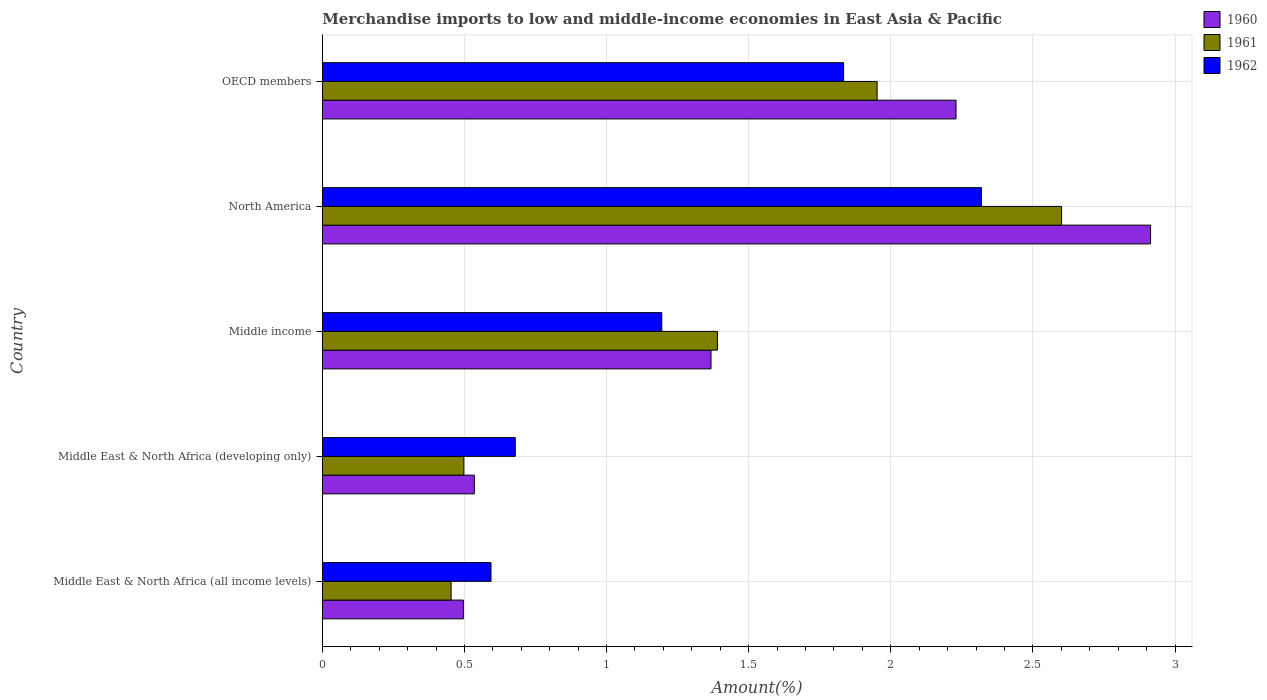How many groups of bars are there?
Your answer should be compact. 5. Are the number of bars on each tick of the Y-axis equal?
Provide a succinct answer. Yes. How many bars are there on the 4th tick from the top?
Offer a terse response. 3. What is the percentage of amount earned from merchandise imports in 1960 in Middle East & North Africa (developing only)?
Offer a terse response. 0.53. Across all countries, what is the maximum percentage of amount earned from merchandise imports in 1960?
Offer a terse response. 2.91. Across all countries, what is the minimum percentage of amount earned from merchandise imports in 1960?
Your answer should be compact. 0.5. In which country was the percentage of amount earned from merchandise imports in 1961 minimum?
Your answer should be very brief. Middle East & North Africa (all income levels). What is the total percentage of amount earned from merchandise imports in 1962 in the graph?
Offer a terse response. 6.62. What is the difference between the percentage of amount earned from merchandise imports in 1962 in Middle East & North Africa (developing only) and that in OECD members?
Keep it short and to the point. -1.16. What is the difference between the percentage of amount earned from merchandise imports in 1960 in Middle income and the percentage of amount earned from merchandise imports in 1961 in OECD members?
Provide a short and direct response. -0.58. What is the average percentage of amount earned from merchandise imports in 1962 per country?
Keep it short and to the point. 1.32. What is the difference between the percentage of amount earned from merchandise imports in 1960 and percentage of amount earned from merchandise imports in 1962 in Middle income?
Offer a very short reply. 0.17. In how many countries, is the percentage of amount earned from merchandise imports in 1960 greater than 0.6 %?
Give a very brief answer. 3. What is the ratio of the percentage of amount earned from merchandise imports in 1960 in Middle income to that in OECD members?
Provide a succinct answer. 0.61. What is the difference between the highest and the second highest percentage of amount earned from merchandise imports in 1961?
Offer a terse response. 0.65. What is the difference between the highest and the lowest percentage of amount earned from merchandise imports in 1962?
Provide a short and direct response. 1.73. What does the 2nd bar from the bottom in Middle East & North Africa (developing only) represents?
Make the answer very short. 1961. How many bars are there?
Offer a terse response. 15. How many countries are there in the graph?
Provide a succinct answer. 5. Does the graph contain any zero values?
Make the answer very short. No. Where does the legend appear in the graph?
Provide a short and direct response. Top right. How are the legend labels stacked?
Offer a very short reply. Vertical. What is the title of the graph?
Make the answer very short. Merchandise imports to low and middle-income economies in East Asia & Pacific. What is the label or title of the X-axis?
Provide a short and direct response. Amount(%). What is the label or title of the Y-axis?
Ensure brevity in your answer.  Country. What is the Amount(%) in 1960 in Middle East & North Africa (all income levels)?
Ensure brevity in your answer.  0.5. What is the Amount(%) of 1961 in Middle East & North Africa (all income levels)?
Give a very brief answer. 0.45. What is the Amount(%) of 1962 in Middle East & North Africa (all income levels)?
Offer a very short reply. 0.59. What is the Amount(%) in 1960 in Middle East & North Africa (developing only)?
Provide a short and direct response. 0.53. What is the Amount(%) of 1961 in Middle East & North Africa (developing only)?
Make the answer very short. 0.5. What is the Amount(%) of 1962 in Middle East & North Africa (developing only)?
Offer a very short reply. 0.68. What is the Amount(%) of 1960 in Middle income?
Keep it short and to the point. 1.37. What is the Amount(%) of 1961 in Middle income?
Give a very brief answer. 1.39. What is the Amount(%) of 1962 in Middle income?
Provide a succinct answer. 1.19. What is the Amount(%) in 1960 in North America?
Give a very brief answer. 2.91. What is the Amount(%) of 1961 in North America?
Give a very brief answer. 2.6. What is the Amount(%) in 1962 in North America?
Ensure brevity in your answer.  2.32. What is the Amount(%) of 1960 in OECD members?
Make the answer very short. 2.23. What is the Amount(%) in 1961 in OECD members?
Provide a succinct answer. 1.95. What is the Amount(%) of 1962 in OECD members?
Give a very brief answer. 1.83. Across all countries, what is the maximum Amount(%) in 1960?
Make the answer very short. 2.91. Across all countries, what is the maximum Amount(%) in 1961?
Your response must be concise. 2.6. Across all countries, what is the maximum Amount(%) in 1962?
Give a very brief answer. 2.32. Across all countries, what is the minimum Amount(%) in 1960?
Ensure brevity in your answer.  0.5. Across all countries, what is the minimum Amount(%) in 1961?
Provide a succinct answer. 0.45. Across all countries, what is the minimum Amount(%) in 1962?
Give a very brief answer. 0.59. What is the total Amount(%) in 1960 in the graph?
Offer a very short reply. 7.54. What is the total Amount(%) in 1961 in the graph?
Keep it short and to the point. 6.89. What is the total Amount(%) of 1962 in the graph?
Give a very brief answer. 6.62. What is the difference between the Amount(%) in 1960 in Middle East & North Africa (all income levels) and that in Middle East & North Africa (developing only)?
Your response must be concise. -0.04. What is the difference between the Amount(%) of 1961 in Middle East & North Africa (all income levels) and that in Middle East & North Africa (developing only)?
Keep it short and to the point. -0.04. What is the difference between the Amount(%) in 1962 in Middle East & North Africa (all income levels) and that in Middle East & North Africa (developing only)?
Provide a short and direct response. -0.09. What is the difference between the Amount(%) of 1960 in Middle East & North Africa (all income levels) and that in Middle income?
Provide a short and direct response. -0.87. What is the difference between the Amount(%) in 1961 in Middle East & North Africa (all income levels) and that in Middle income?
Make the answer very short. -0.94. What is the difference between the Amount(%) in 1962 in Middle East & North Africa (all income levels) and that in Middle income?
Provide a succinct answer. -0.6. What is the difference between the Amount(%) of 1960 in Middle East & North Africa (all income levels) and that in North America?
Your answer should be compact. -2.42. What is the difference between the Amount(%) in 1961 in Middle East & North Africa (all income levels) and that in North America?
Make the answer very short. -2.15. What is the difference between the Amount(%) in 1962 in Middle East & North Africa (all income levels) and that in North America?
Offer a terse response. -1.73. What is the difference between the Amount(%) in 1960 in Middle East & North Africa (all income levels) and that in OECD members?
Ensure brevity in your answer.  -1.73. What is the difference between the Amount(%) in 1961 in Middle East & North Africa (all income levels) and that in OECD members?
Ensure brevity in your answer.  -1.5. What is the difference between the Amount(%) in 1962 in Middle East & North Africa (all income levels) and that in OECD members?
Provide a succinct answer. -1.24. What is the difference between the Amount(%) in 1960 in Middle East & North Africa (developing only) and that in Middle income?
Your answer should be very brief. -0.83. What is the difference between the Amount(%) in 1961 in Middle East & North Africa (developing only) and that in Middle income?
Your answer should be compact. -0.89. What is the difference between the Amount(%) of 1962 in Middle East & North Africa (developing only) and that in Middle income?
Make the answer very short. -0.52. What is the difference between the Amount(%) of 1960 in Middle East & North Africa (developing only) and that in North America?
Your response must be concise. -2.38. What is the difference between the Amount(%) of 1961 in Middle East & North Africa (developing only) and that in North America?
Provide a short and direct response. -2.1. What is the difference between the Amount(%) of 1962 in Middle East & North Africa (developing only) and that in North America?
Provide a succinct answer. -1.64. What is the difference between the Amount(%) in 1960 in Middle East & North Africa (developing only) and that in OECD members?
Give a very brief answer. -1.69. What is the difference between the Amount(%) of 1961 in Middle East & North Africa (developing only) and that in OECD members?
Provide a succinct answer. -1.45. What is the difference between the Amount(%) in 1962 in Middle East & North Africa (developing only) and that in OECD members?
Provide a succinct answer. -1.16. What is the difference between the Amount(%) in 1960 in Middle income and that in North America?
Offer a terse response. -1.55. What is the difference between the Amount(%) in 1961 in Middle income and that in North America?
Keep it short and to the point. -1.21. What is the difference between the Amount(%) in 1962 in Middle income and that in North America?
Keep it short and to the point. -1.12. What is the difference between the Amount(%) in 1960 in Middle income and that in OECD members?
Give a very brief answer. -0.86. What is the difference between the Amount(%) of 1961 in Middle income and that in OECD members?
Provide a short and direct response. -0.56. What is the difference between the Amount(%) of 1962 in Middle income and that in OECD members?
Your response must be concise. -0.64. What is the difference between the Amount(%) in 1960 in North America and that in OECD members?
Make the answer very short. 0.68. What is the difference between the Amount(%) of 1961 in North America and that in OECD members?
Your response must be concise. 0.65. What is the difference between the Amount(%) in 1962 in North America and that in OECD members?
Your answer should be very brief. 0.48. What is the difference between the Amount(%) in 1960 in Middle East & North Africa (all income levels) and the Amount(%) in 1961 in Middle East & North Africa (developing only)?
Provide a succinct answer. -0. What is the difference between the Amount(%) of 1960 in Middle East & North Africa (all income levels) and the Amount(%) of 1962 in Middle East & North Africa (developing only)?
Keep it short and to the point. -0.18. What is the difference between the Amount(%) of 1961 in Middle East & North Africa (all income levels) and the Amount(%) of 1962 in Middle East & North Africa (developing only)?
Give a very brief answer. -0.23. What is the difference between the Amount(%) of 1960 in Middle East & North Africa (all income levels) and the Amount(%) of 1961 in Middle income?
Offer a terse response. -0.89. What is the difference between the Amount(%) of 1960 in Middle East & North Africa (all income levels) and the Amount(%) of 1962 in Middle income?
Offer a terse response. -0.7. What is the difference between the Amount(%) of 1961 in Middle East & North Africa (all income levels) and the Amount(%) of 1962 in Middle income?
Your answer should be very brief. -0.74. What is the difference between the Amount(%) in 1960 in Middle East & North Africa (all income levels) and the Amount(%) in 1961 in North America?
Your answer should be compact. -2.1. What is the difference between the Amount(%) in 1960 in Middle East & North Africa (all income levels) and the Amount(%) in 1962 in North America?
Offer a very short reply. -1.82. What is the difference between the Amount(%) of 1961 in Middle East & North Africa (all income levels) and the Amount(%) of 1962 in North America?
Your response must be concise. -1.87. What is the difference between the Amount(%) in 1960 in Middle East & North Africa (all income levels) and the Amount(%) in 1961 in OECD members?
Ensure brevity in your answer.  -1.46. What is the difference between the Amount(%) of 1960 in Middle East & North Africa (all income levels) and the Amount(%) of 1962 in OECD members?
Offer a very short reply. -1.34. What is the difference between the Amount(%) of 1961 in Middle East & North Africa (all income levels) and the Amount(%) of 1962 in OECD members?
Your answer should be very brief. -1.38. What is the difference between the Amount(%) of 1960 in Middle East & North Africa (developing only) and the Amount(%) of 1961 in Middle income?
Keep it short and to the point. -0.86. What is the difference between the Amount(%) in 1960 in Middle East & North Africa (developing only) and the Amount(%) in 1962 in Middle income?
Your answer should be very brief. -0.66. What is the difference between the Amount(%) in 1961 in Middle East & North Africa (developing only) and the Amount(%) in 1962 in Middle income?
Offer a very short reply. -0.7. What is the difference between the Amount(%) in 1960 in Middle East & North Africa (developing only) and the Amount(%) in 1961 in North America?
Provide a short and direct response. -2.07. What is the difference between the Amount(%) of 1960 in Middle East & North Africa (developing only) and the Amount(%) of 1962 in North America?
Your answer should be very brief. -1.78. What is the difference between the Amount(%) in 1961 in Middle East & North Africa (developing only) and the Amount(%) in 1962 in North America?
Offer a very short reply. -1.82. What is the difference between the Amount(%) of 1960 in Middle East & North Africa (developing only) and the Amount(%) of 1961 in OECD members?
Your response must be concise. -1.42. What is the difference between the Amount(%) of 1960 in Middle East & North Africa (developing only) and the Amount(%) of 1962 in OECD members?
Your answer should be compact. -1.3. What is the difference between the Amount(%) in 1961 in Middle East & North Africa (developing only) and the Amount(%) in 1962 in OECD members?
Provide a succinct answer. -1.34. What is the difference between the Amount(%) in 1960 in Middle income and the Amount(%) in 1961 in North America?
Your response must be concise. -1.23. What is the difference between the Amount(%) of 1960 in Middle income and the Amount(%) of 1962 in North America?
Offer a very short reply. -0.95. What is the difference between the Amount(%) in 1961 in Middle income and the Amount(%) in 1962 in North America?
Offer a terse response. -0.93. What is the difference between the Amount(%) in 1960 in Middle income and the Amount(%) in 1961 in OECD members?
Your answer should be compact. -0.58. What is the difference between the Amount(%) in 1960 in Middle income and the Amount(%) in 1962 in OECD members?
Give a very brief answer. -0.47. What is the difference between the Amount(%) of 1961 in Middle income and the Amount(%) of 1962 in OECD members?
Ensure brevity in your answer.  -0.44. What is the difference between the Amount(%) in 1960 in North America and the Amount(%) in 1961 in OECD members?
Keep it short and to the point. 0.96. What is the difference between the Amount(%) of 1960 in North America and the Amount(%) of 1962 in OECD members?
Offer a very short reply. 1.08. What is the difference between the Amount(%) in 1961 in North America and the Amount(%) in 1962 in OECD members?
Keep it short and to the point. 0.77. What is the average Amount(%) of 1960 per country?
Make the answer very short. 1.51. What is the average Amount(%) of 1961 per country?
Offer a terse response. 1.38. What is the average Amount(%) of 1962 per country?
Ensure brevity in your answer.  1.32. What is the difference between the Amount(%) in 1960 and Amount(%) in 1961 in Middle East & North Africa (all income levels)?
Ensure brevity in your answer.  0.04. What is the difference between the Amount(%) in 1960 and Amount(%) in 1962 in Middle East & North Africa (all income levels)?
Offer a very short reply. -0.1. What is the difference between the Amount(%) in 1961 and Amount(%) in 1962 in Middle East & North Africa (all income levels)?
Keep it short and to the point. -0.14. What is the difference between the Amount(%) in 1960 and Amount(%) in 1961 in Middle East & North Africa (developing only)?
Give a very brief answer. 0.04. What is the difference between the Amount(%) in 1960 and Amount(%) in 1962 in Middle East & North Africa (developing only)?
Keep it short and to the point. -0.14. What is the difference between the Amount(%) in 1961 and Amount(%) in 1962 in Middle East & North Africa (developing only)?
Provide a short and direct response. -0.18. What is the difference between the Amount(%) of 1960 and Amount(%) of 1961 in Middle income?
Give a very brief answer. -0.02. What is the difference between the Amount(%) of 1960 and Amount(%) of 1962 in Middle income?
Give a very brief answer. 0.17. What is the difference between the Amount(%) of 1961 and Amount(%) of 1962 in Middle income?
Offer a terse response. 0.2. What is the difference between the Amount(%) in 1960 and Amount(%) in 1961 in North America?
Your answer should be very brief. 0.31. What is the difference between the Amount(%) in 1960 and Amount(%) in 1962 in North America?
Provide a short and direct response. 0.6. What is the difference between the Amount(%) in 1961 and Amount(%) in 1962 in North America?
Provide a succinct answer. 0.28. What is the difference between the Amount(%) in 1960 and Amount(%) in 1961 in OECD members?
Keep it short and to the point. 0.28. What is the difference between the Amount(%) in 1960 and Amount(%) in 1962 in OECD members?
Your answer should be compact. 0.4. What is the difference between the Amount(%) in 1961 and Amount(%) in 1962 in OECD members?
Provide a short and direct response. 0.12. What is the ratio of the Amount(%) of 1960 in Middle East & North Africa (all income levels) to that in Middle East & North Africa (developing only)?
Your response must be concise. 0.93. What is the ratio of the Amount(%) in 1961 in Middle East & North Africa (all income levels) to that in Middle East & North Africa (developing only)?
Give a very brief answer. 0.91. What is the ratio of the Amount(%) in 1962 in Middle East & North Africa (all income levels) to that in Middle East & North Africa (developing only)?
Keep it short and to the point. 0.87. What is the ratio of the Amount(%) of 1960 in Middle East & North Africa (all income levels) to that in Middle income?
Give a very brief answer. 0.36. What is the ratio of the Amount(%) in 1961 in Middle East & North Africa (all income levels) to that in Middle income?
Offer a very short reply. 0.33. What is the ratio of the Amount(%) in 1962 in Middle East & North Africa (all income levels) to that in Middle income?
Provide a short and direct response. 0.5. What is the ratio of the Amount(%) in 1960 in Middle East & North Africa (all income levels) to that in North America?
Make the answer very short. 0.17. What is the ratio of the Amount(%) of 1961 in Middle East & North Africa (all income levels) to that in North America?
Your answer should be compact. 0.17. What is the ratio of the Amount(%) of 1962 in Middle East & North Africa (all income levels) to that in North America?
Your answer should be very brief. 0.26. What is the ratio of the Amount(%) of 1960 in Middle East & North Africa (all income levels) to that in OECD members?
Your response must be concise. 0.22. What is the ratio of the Amount(%) of 1961 in Middle East & North Africa (all income levels) to that in OECD members?
Offer a very short reply. 0.23. What is the ratio of the Amount(%) of 1962 in Middle East & North Africa (all income levels) to that in OECD members?
Provide a succinct answer. 0.32. What is the ratio of the Amount(%) in 1960 in Middle East & North Africa (developing only) to that in Middle income?
Ensure brevity in your answer.  0.39. What is the ratio of the Amount(%) of 1961 in Middle East & North Africa (developing only) to that in Middle income?
Your response must be concise. 0.36. What is the ratio of the Amount(%) in 1962 in Middle East & North Africa (developing only) to that in Middle income?
Your answer should be very brief. 0.57. What is the ratio of the Amount(%) in 1960 in Middle East & North Africa (developing only) to that in North America?
Give a very brief answer. 0.18. What is the ratio of the Amount(%) in 1961 in Middle East & North Africa (developing only) to that in North America?
Keep it short and to the point. 0.19. What is the ratio of the Amount(%) of 1962 in Middle East & North Africa (developing only) to that in North America?
Your answer should be very brief. 0.29. What is the ratio of the Amount(%) in 1960 in Middle East & North Africa (developing only) to that in OECD members?
Offer a very short reply. 0.24. What is the ratio of the Amount(%) in 1961 in Middle East & North Africa (developing only) to that in OECD members?
Ensure brevity in your answer.  0.26. What is the ratio of the Amount(%) of 1962 in Middle East & North Africa (developing only) to that in OECD members?
Your answer should be very brief. 0.37. What is the ratio of the Amount(%) of 1960 in Middle income to that in North America?
Ensure brevity in your answer.  0.47. What is the ratio of the Amount(%) of 1961 in Middle income to that in North America?
Your answer should be very brief. 0.53. What is the ratio of the Amount(%) in 1962 in Middle income to that in North America?
Your answer should be compact. 0.52. What is the ratio of the Amount(%) of 1960 in Middle income to that in OECD members?
Keep it short and to the point. 0.61. What is the ratio of the Amount(%) of 1961 in Middle income to that in OECD members?
Make the answer very short. 0.71. What is the ratio of the Amount(%) in 1962 in Middle income to that in OECD members?
Keep it short and to the point. 0.65. What is the ratio of the Amount(%) of 1960 in North America to that in OECD members?
Your response must be concise. 1.31. What is the ratio of the Amount(%) of 1961 in North America to that in OECD members?
Your response must be concise. 1.33. What is the ratio of the Amount(%) in 1962 in North America to that in OECD members?
Give a very brief answer. 1.26. What is the difference between the highest and the second highest Amount(%) in 1960?
Keep it short and to the point. 0.68. What is the difference between the highest and the second highest Amount(%) of 1961?
Provide a succinct answer. 0.65. What is the difference between the highest and the second highest Amount(%) in 1962?
Make the answer very short. 0.48. What is the difference between the highest and the lowest Amount(%) of 1960?
Ensure brevity in your answer.  2.42. What is the difference between the highest and the lowest Amount(%) of 1961?
Make the answer very short. 2.15. What is the difference between the highest and the lowest Amount(%) of 1962?
Your response must be concise. 1.73. 